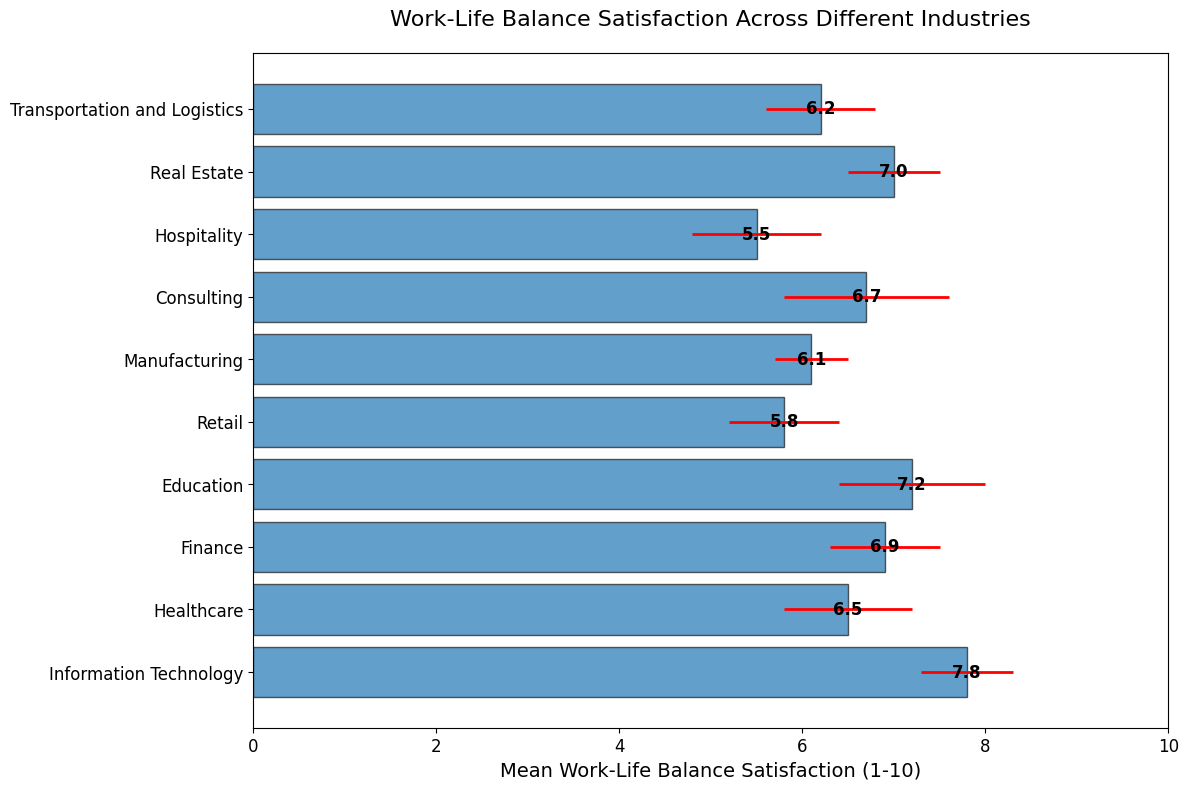What's the industry with the highest work-life balance satisfaction? Identify the tallest bar in the chart. The tallest bar represents Information Technology with a mean satisfaction of 7.8.
Answer: Information Technology Which industry has the lowest work-life balance satisfaction? Identify the shortest bar in the chart. The shortest bar represents Hospitality with a mean satisfaction of 5.5.
Answer: Hospitality How do Healthcare and Finance compare in terms of work-life balance satisfaction? Compare the heights of the bars for Healthcare (6.5 with a std deviation of 0.7) and Finance (6.9 with a std deviation of 0.6). Finance has a higher mean satisfaction than Healthcare.
Answer: Finance has higher satisfaction What is the total sample size used to evaluate work-life balance satisfaction across all industries? Sum the sample sizes from all the industries. This is 150 + 100 + 120 + 130 + 110 + 90 + 95 + 80 + 60 + 85 = 1020.
Answer: 1020 Which industries have a mean work-life balance satisfaction greater than 7? Identify bars with lengths greater than 7. This includes Information Technology (7.8), Education (7.2), and Real Estate (7).
Answer: Information Technology, Education, Real Estate What is the difference in mean satisfaction between Information Technology and Retail? Subtract the mean satisfaction of Retail (5.8) from Information Technology (7.8). This is 7.8 - 5.8 = 2.0.
Answer: 2.0 Which industry has the largest standard deviation in work-life balance satisfaction? Identify the bar with the longest error bar (red). Consulting has the largest standard deviation of 0.9.
Answer: Consulting How does the mean satisfaction of Manufacturing compare to that of Transportation and Logistics? Compare the mean satisfaction values of Manufacturing (6.1) and Transportation and Logistics (6.2). Transportation and Logistics have slightly higher satisfaction than Manufacturing.
Answer: Transportation and Logistics has higher satisfaction What is the average mean satisfaction of all industries? Sum all mean satisfaction values and divide by the number of industries. This is (7.8 + 6.5 + 6.9 + 7.2 + 5.8 + 6.1 + 6.7 + 5.5 + 7.0 + 6.2) / 10 = 6.57.
Answer: 6.57 Which industry has a mean work-life balance satisfaction closest to the overall average satisfaction? Calculate the average satisfaction (6.57) and find the industry whose mean is closest to this value. Transportation and Logistics has a mean satisfaction of 6.2, which is closest to 6.57.
Answer: Transportation and Logistics 